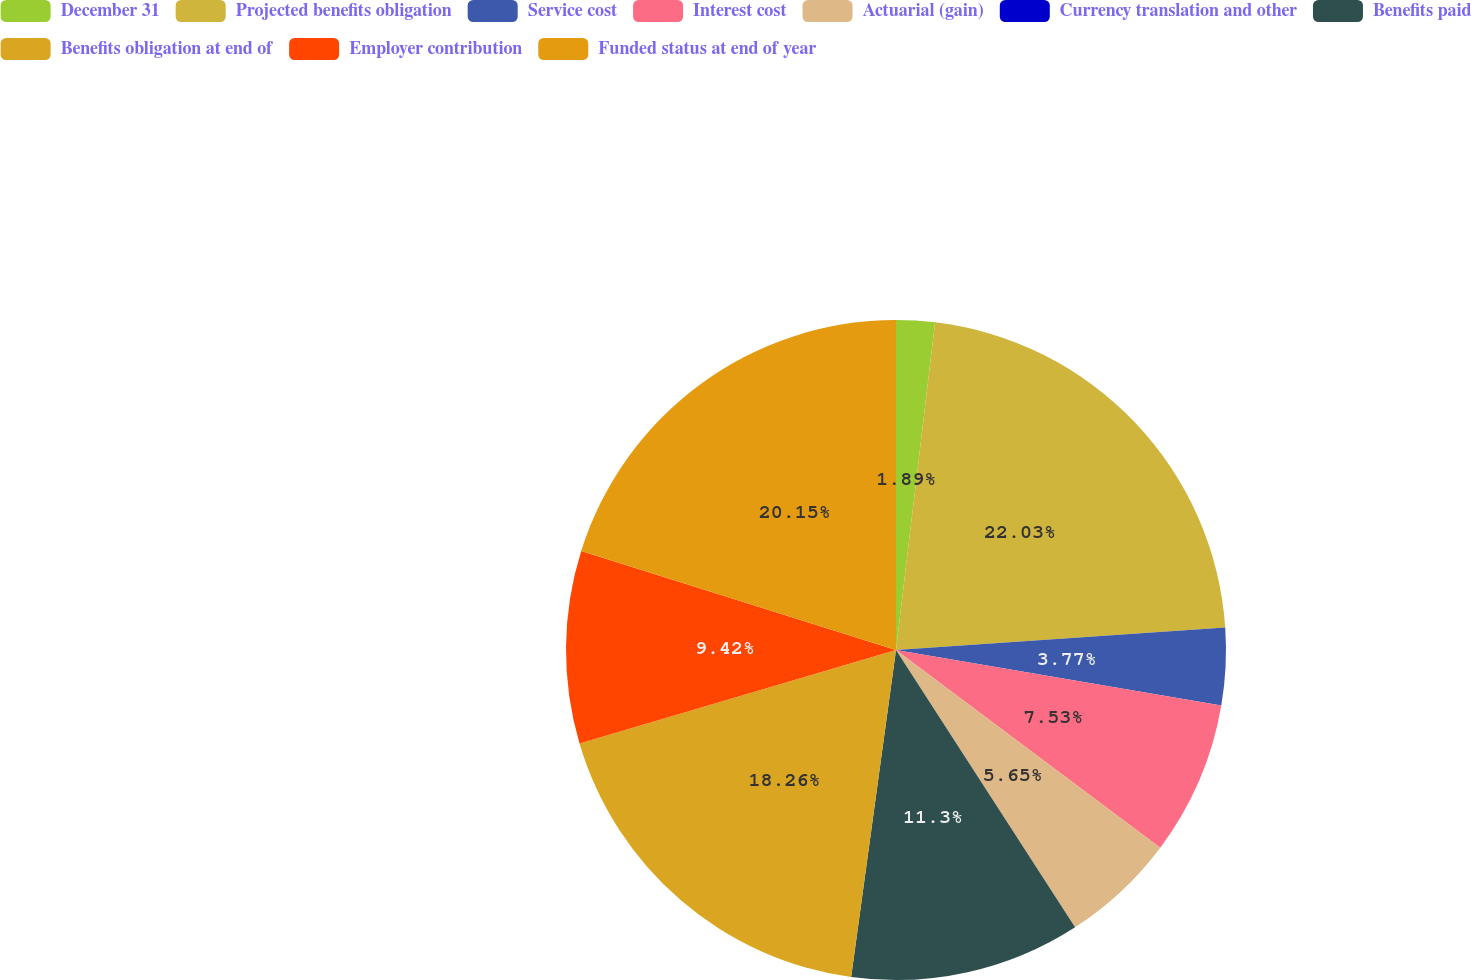Convert chart. <chart><loc_0><loc_0><loc_500><loc_500><pie_chart><fcel>December 31<fcel>Projected benefits obligation<fcel>Service cost<fcel>Interest cost<fcel>Actuarial (gain)<fcel>Currency translation and other<fcel>Benefits paid<fcel>Benefits obligation at end of<fcel>Employer contribution<fcel>Funded status at end of year<nl><fcel>1.89%<fcel>22.03%<fcel>3.77%<fcel>7.53%<fcel>5.65%<fcel>0.0%<fcel>11.3%<fcel>18.26%<fcel>9.42%<fcel>20.15%<nl></chart> 